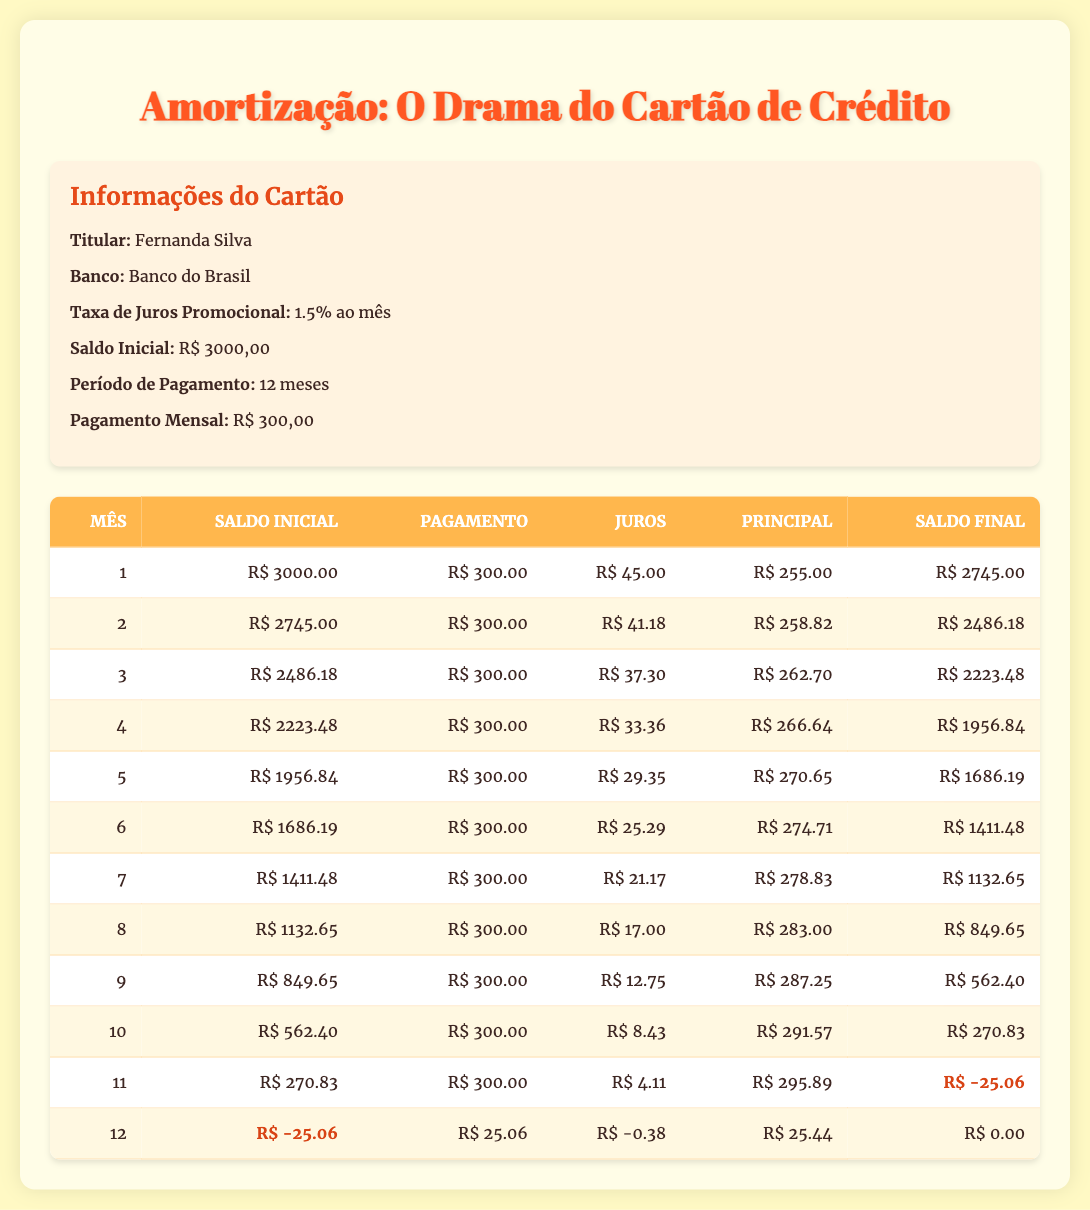What is the initial balance on Fernanda's credit card? The initial balance is clearly provided in the credit information section of the table, which states that the saldo inicial (initial balance) is 3000,00.
Answer: 3000,00 What was the ending balance after the first month? Referring to the first month in the amortization schedule, the ending balance is listed as 2745,00.
Answer: 2745,00 How much interest was paid in the third month? In the third month, the corresponding value for interest in the amortization schedule is specified as 37,30.
Answer: 37,30 What is the total payment made over the entire payment period? Since the monthly payment is 300 and the payment period is 12 months, the total payment is calculated as 300 multiplied by 12, which equals 3600.
Answer: 3600 Did Fernanda incur any additional debt at the end of the eleventh month? The ending balance for the eleventh month is shown as -25,06, indicating that Fernanda not only reached a zero balance but also incurred extra debt. Thus, the answer is yes.
Answer: Yes In which month did the principal payment exceed 270? By analyzing the principal payments in the schedule, it can be seen that in months 5, 6, and 7, principal payments exceeded 270, specifically 270,65, 274,71, and 278,83 respectively. The first instance is in month 5.
Answer: Month 5 What was the average interest paid during the payment period? To find the average interest, sum the interest amounts from all twelve months (45 + 41.18 + 37.30 + 33.36 + 29.35 + 25.29 + 21.17 + 17 + 12.75 + 8.43 + 4.11 - 0.38), which totals approximately 275.76. Dividing this by 12 gives an average of about 22.98.
Answer: 22.98 What was the highest principal payment made in a single month? Scanning through the principal amounts across months, the highest amount is noted in the eleventh month where it is equal to 295.89.
Answer: 295.89 Did the total amount paid at the end of 12 months reach zero? In the final month, the ending balance is stated as 0, confirming that the payments made successfully cleared out the debt. Thus, the answer is yes.
Answer: Yes 